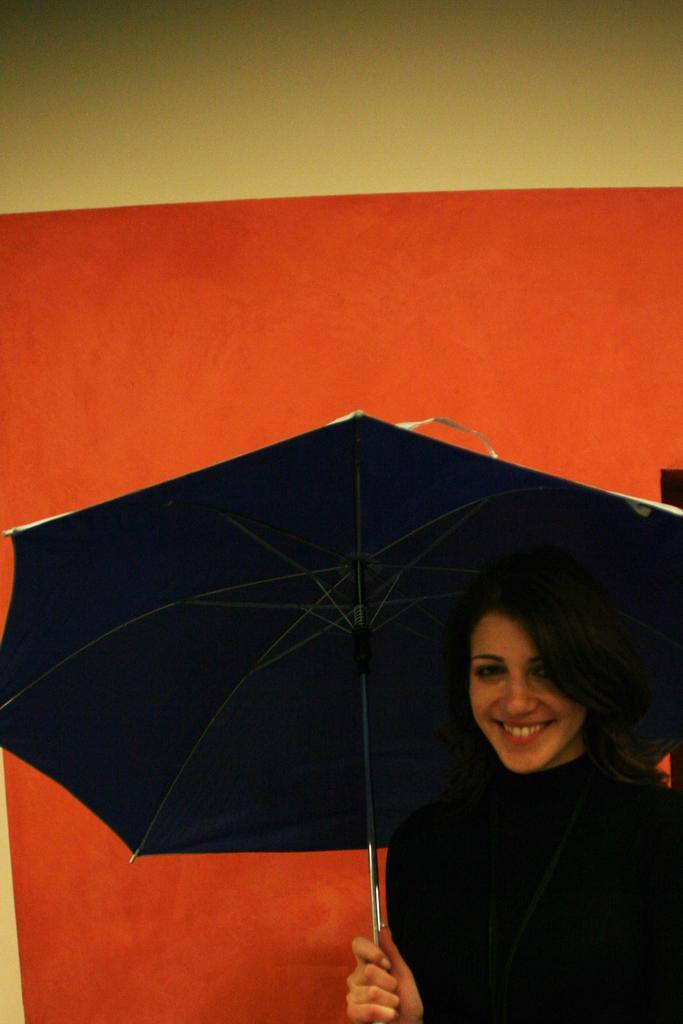Can you describe this image briefly? In this picture we can see a woman holding an umbrella in her hand and smiling. A wall is visible in the background. 